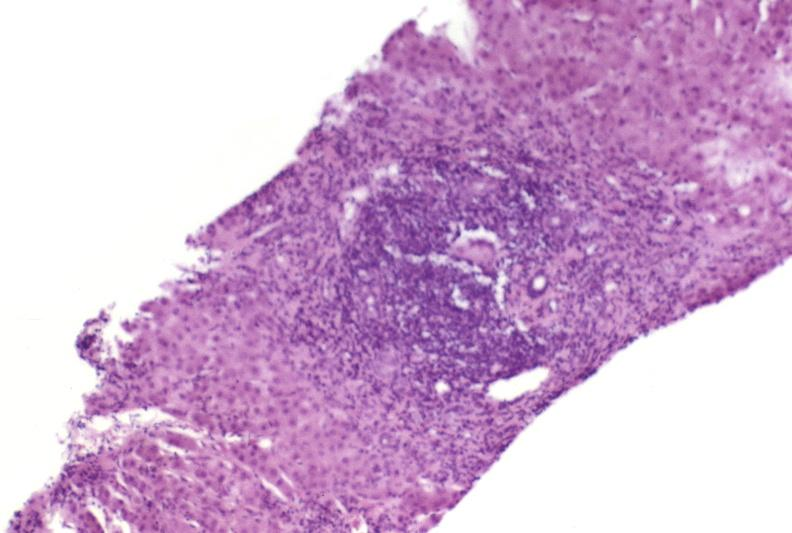s endocervical polyp present?
Answer the question using a single word or phrase. No 